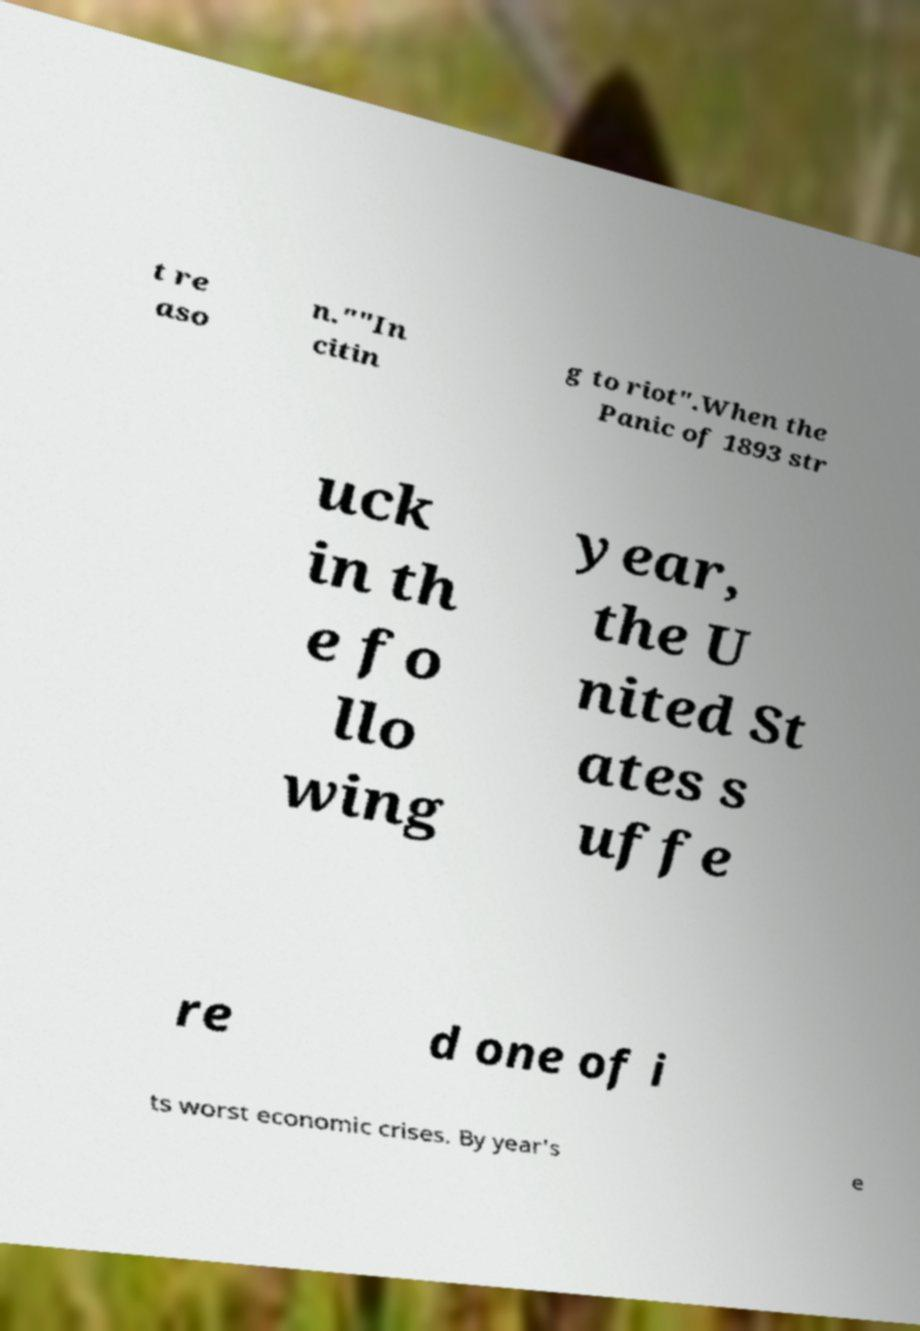There's text embedded in this image that I need extracted. Can you transcribe it verbatim? t re aso n.""In citin g to riot".When the Panic of 1893 str uck in th e fo llo wing year, the U nited St ates s uffe re d one of i ts worst economic crises. By year's e 